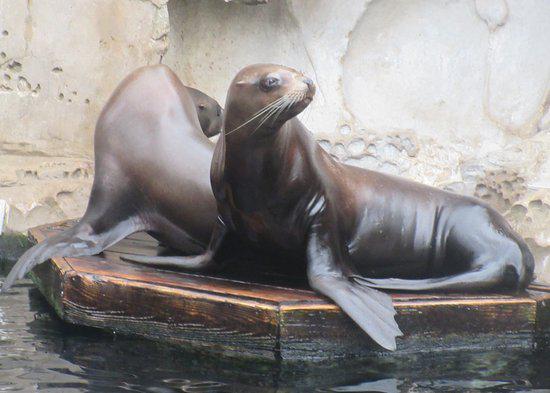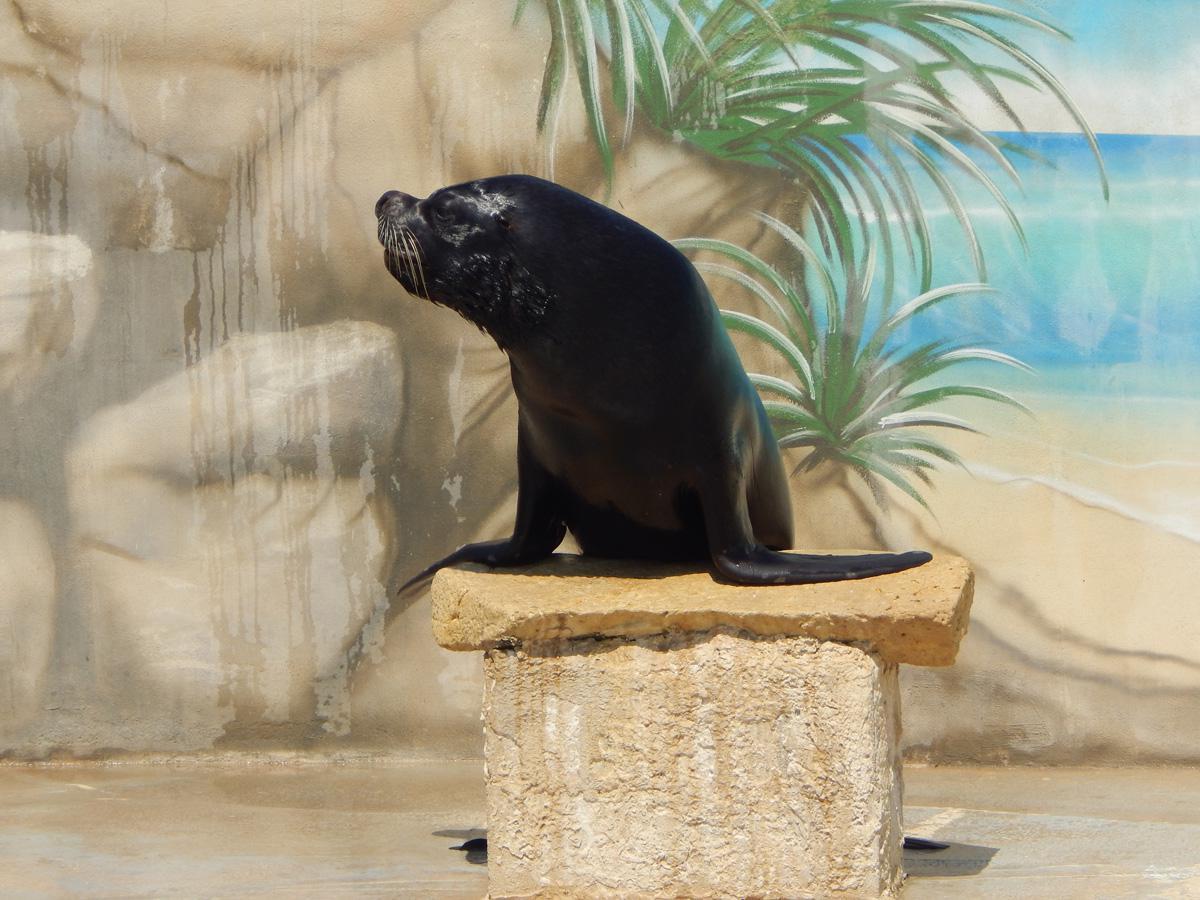The first image is the image on the left, the second image is the image on the right. Given the left and right images, does the statement "There is one trainer working with a seal in the image on the left." hold true? Answer yes or no. No. The first image is the image on the left, the second image is the image on the right. Considering the images on both sides, is "A man is interacting with one of the seals." valid? Answer yes or no. No. 